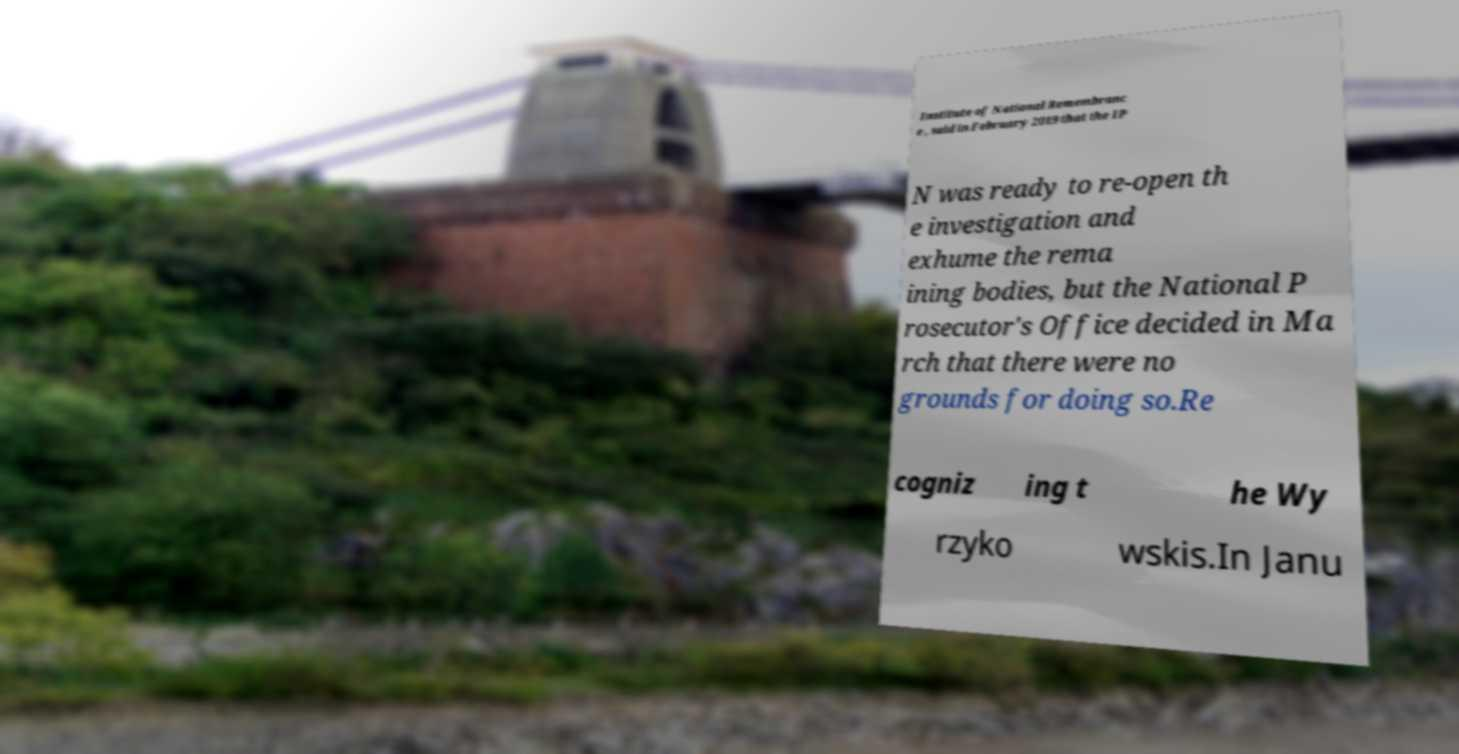Could you assist in decoding the text presented in this image and type it out clearly? Institute of National Remembranc e , said in February 2019 that the IP N was ready to re-open th e investigation and exhume the rema ining bodies, but the National P rosecutor's Office decided in Ma rch that there were no grounds for doing so.Re cogniz ing t he Wy rzyko wskis.In Janu 